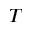Convert formula to latex. <formula><loc_0><loc_0><loc_500><loc_500>T</formula> 